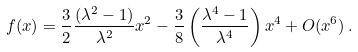Convert formula to latex. <formula><loc_0><loc_0><loc_500><loc_500>f ( x ) = { \frac { 3 } { 2 } } { \frac { ( \lambda ^ { 2 } - 1 ) } { \lambda ^ { 2 } } } x ^ { 2 } - { \frac { 3 } { 8 } } \left ( { \frac { \lambda ^ { 4 } - 1 } { \lambda ^ { 4 } } } \right ) x ^ { 4 } + O ( x ^ { 6 } ) \, .</formula> 